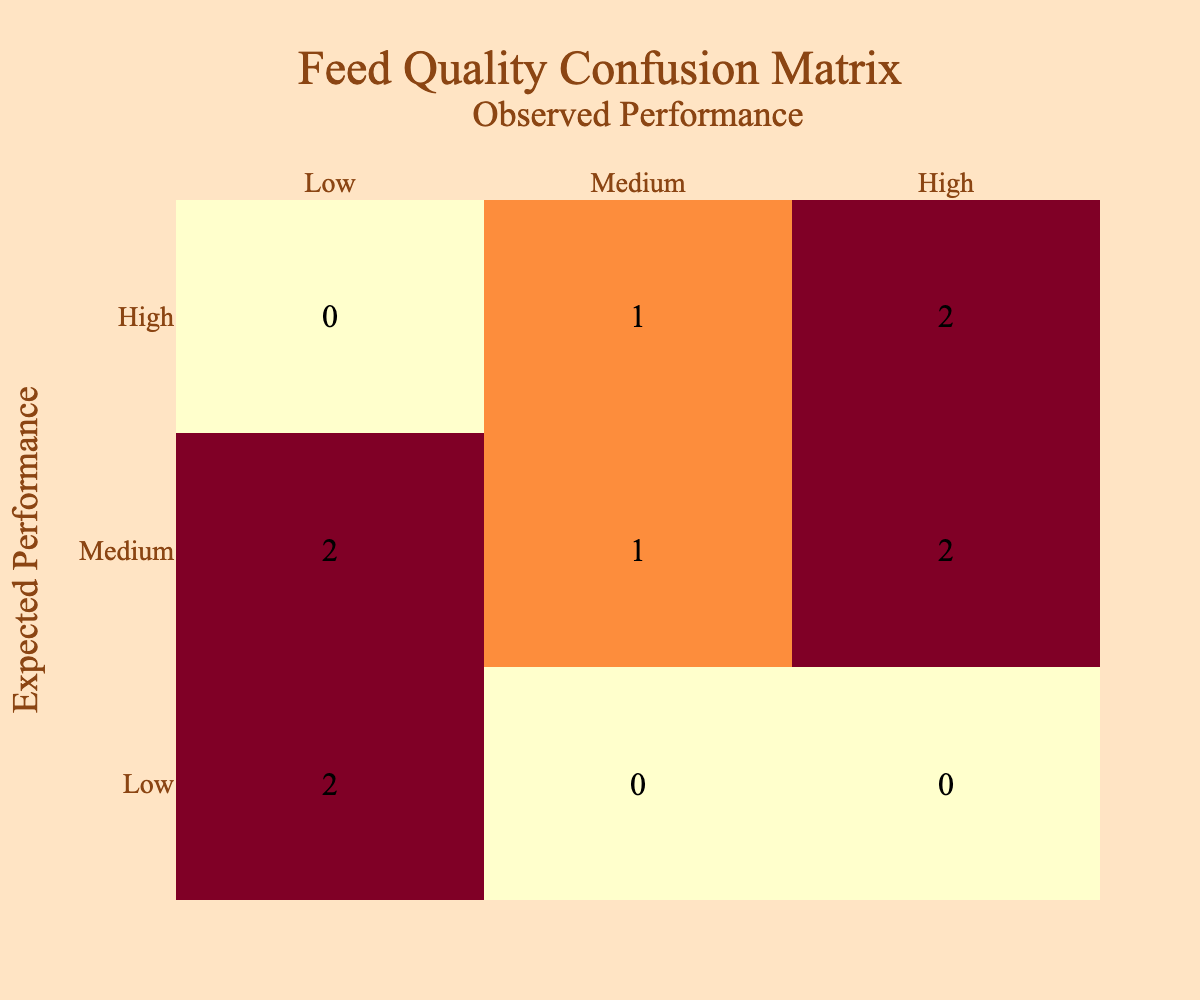What is the total number of feed types that had low observed performance? By referring to the matrix, we count the values in the column for "Low" under the "Observed Performance" category. There are three entries: Bran Mash, Oilseed Cake, and Straw, which results in a total of 3 feed types.
Answer: 3 Which feed type had the highest number of mismatches between expected and observed performance? Looking at the matrix, we find the row "High" under Expected Performance and see the observed values. Only Alfalfa Hay shows a mismatch (expected: High, observed: Medium). It is the only feed type in the High category with a mismatch.
Answer: Alfalfa Hay True or False: All feed types that were expected to have high performance actually performed high. Analyzing the expected performance of high feed types: Pasture Grazing and Pelleted Feed had high observed performances. However, Alfalfa Hay had an expected performance of high but an observed performance of medium. Therefore, the statement is false.
Answer: False What is the observed performance of Mixed Grain Feed? To answer this, we locate the row for Mixed Grain Feed in the table, where the observed performance is indicated as low.
Answer: Low How many feed types performed better than expected? We examine the "Observed Performance" column against the "Expected Performance" column. Fresh Vegetables, Lucerne Hay, and Pasture Grazing exhibit better performance, as their observed performance is higher than expected. That's a total of 3 feed types.
Answer: 3 